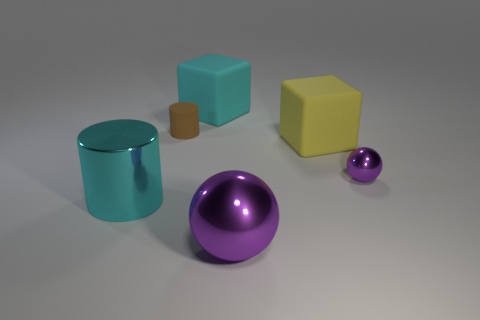What could be the possible use for these objects? These objects appear to be 3D renderings and could be used for various purposes. They might serve as visual aids in an educational setting to teach about geometry, volume, and spatial awareness. Alternatively, they could be assets for a computer graphics project, like a video game or an animation, serving as props or placeholders during the creative process.  How does the lighting affect the mood or quality of the scene? The lighting in the image is soft and diffused, producing gentle shadows and giving the scene a calm and neutral mood. It appears to be studio lighting, commonly used in product visualization to highlight the form and color of the objects without creating harsh shadows or reflections. This type of lighting makes the objects the main focus and is ideal for examining their details. 